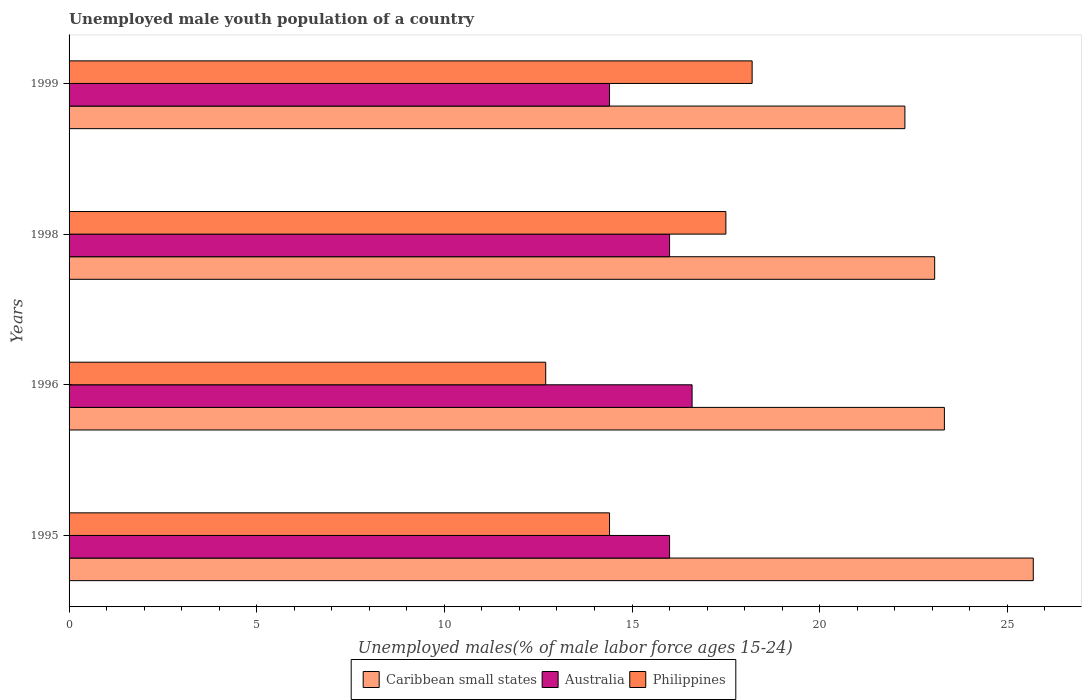How many different coloured bars are there?
Make the answer very short. 3. Are the number of bars per tick equal to the number of legend labels?
Your answer should be very brief. Yes. What is the label of the 1st group of bars from the top?
Provide a short and direct response. 1999. In how many cases, is the number of bars for a given year not equal to the number of legend labels?
Ensure brevity in your answer.  0. What is the percentage of unemployed male youth population in Caribbean small states in 1995?
Your answer should be compact. 25.69. Across all years, what is the maximum percentage of unemployed male youth population in Caribbean small states?
Your answer should be very brief. 25.69. Across all years, what is the minimum percentage of unemployed male youth population in Caribbean small states?
Make the answer very short. 22.27. In which year was the percentage of unemployed male youth population in Australia maximum?
Keep it short and to the point. 1996. What is the total percentage of unemployed male youth population in Caribbean small states in the graph?
Offer a very short reply. 94.35. What is the difference between the percentage of unemployed male youth population in Caribbean small states in 1995 and that in 1998?
Keep it short and to the point. 2.63. What is the difference between the percentage of unemployed male youth population in Australia in 1998 and the percentage of unemployed male youth population in Philippines in 1995?
Your answer should be compact. 1.6. What is the average percentage of unemployed male youth population in Australia per year?
Your answer should be compact. 15.75. In the year 1998, what is the difference between the percentage of unemployed male youth population in Caribbean small states and percentage of unemployed male youth population in Australia?
Ensure brevity in your answer.  7.06. What is the ratio of the percentage of unemployed male youth population in Caribbean small states in 1996 to that in 1999?
Your answer should be compact. 1.05. What is the difference between the highest and the second highest percentage of unemployed male youth population in Caribbean small states?
Make the answer very short. 2.37. What is the difference between the highest and the lowest percentage of unemployed male youth population in Caribbean small states?
Offer a very short reply. 3.42. What does the 3rd bar from the bottom in 1999 represents?
Give a very brief answer. Philippines. How many bars are there?
Provide a short and direct response. 12. Are all the bars in the graph horizontal?
Make the answer very short. Yes. What is the difference between two consecutive major ticks on the X-axis?
Keep it short and to the point. 5. What is the title of the graph?
Ensure brevity in your answer.  Unemployed male youth population of a country. What is the label or title of the X-axis?
Your response must be concise. Unemployed males(% of male labor force ages 15-24). What is the Unemployed males(% of male labor force ages 15-24) in Caribbean small states in 1995?
Provide a short and direct response. 25.69. What is the Unemployed males(% of male labor force ages 15-24) in Australia in 1995?
Keep it short and to the point. 16. What is the Unemployed males(% of male labor force ages 15-24) in Philippines in 1995?
Keep it short and to the point. 14.4. What is the Unemployed males(% of male labor force ages 15-24) of Caribbean small states in 1996?
Make the answer very short. 23.32. What is the Unemployed males(% of male labor force ages 15-24) of Australia in 1996?
Keep it short and to the point. 16.6. What is the Unemployed males(% of male labor force ages 15-24) in Philippines in 1996?
Provide a short and direct response. 12.7. What is the Unemployed males(% of male labor force ages 15-24) in Caribbean small states in 1998?
Provide a short and direct response. 23.06. What is the Unemployed males(% of male labor force ages 15-24) in Philippines in 1998?
Offer a terse response. 17.5. What is the Unemployed males(% of male labor force ages 15-24) of Caribbean small states in 1999?
Your answer should be compact. 22.27. What is the Unemployed males(% of male labor force ages 15-24) in Australia in 1999?
Offer a very short reply. 14.4. What is the Unemployed males(% of male labor force ages 15-24) of Philippines in 1999?
Keep it short and to the point. 18.2. Across all years, what is the maximum Unemployed males(% of male labor force ages 15-24) in Caribbean small states?
Make the answer very short. 25.69. Across all years, what is the maximum Unemployed males(% of male labor force ages 15-24) in Australia?
Offer a very short reply. 16.6. Across all years, what is the maximum Unemployed males(% of male labor force ages 15-24) of Philippines?
Ensure brevity in your answer.  18.2. Across all years, what is the minimum Unemployed males(% of male labor force ages 15-24) of Caribbean small states?
Keep it short and to the point. 22.27. Across all years, what is the minimum Unemployed males(% of male labor force ages 15-24) in Australia?
Your response must be concise. 14.4. Across all years, what is the minimum Unemployed males(% of male labor force ages 15-24) of Philippines?
Your answer should be very brief. 12.7. What is the total Unemployed males(% of male labor force ages 15-24) in Caribbean small states in the graph?
Make the answer very short. 94.35. What is the total Unemployed males(% of male labor force ages 15-24) of Philippines in the graph?
Give a very brief answer. 62.8. What is the difference between the Unemployed males(% of male labor force ages 15-24) in Caribbean small states in 1995 and that in 1996?
Your answer should be very brief. 2.37. What is the difference between the Unemployed males(% of male labor force ages 15-24) in Caribbean small states in 1995 and that in 1998?
Make the answer very short. 2.63. What is the difference between the Unemployed males(% of male labor force ages 15-24) of Philippines in 1995 and that in 1998?
Offer a terse response. -3.1. What is the difference between the Unemployed males(% of male labor force ages 15-24) of Caribbean small states in 1995 and that in 1999?
Offer a terse response. 3.42. What is the difference between the Unemployed males(% of male labor force ages 15-24) in Philippines in 1995 and that in 1999?
Provide a short and direct response. -3.8. What is the difference between the Unemployed males(% of male labor force ages 15-24) in Caribbean small states in 1996 and that in 1998?
Provide a short and direct response. 0.26. What is the difference between the Unemployed males(% of male labor force ages 15-24) in Philippines in 1996 and that in 1998?
Ensure brevity in your answer.  -4.8. What is the difference between the Unemployed males(% of male labor force ages 15-24) of Caribbean small states in 1996 and that in 1999?
Provide a succinct answer. 1.05. What is the difference between the Unemployed males(% of male labor force ages 15-24) in Australia in 1996 and that in 1999?
Ensure brevity in your answer.  2.2. What is the difference between the Unemployed males(% of male labor force ages 15-24) in Philippines in 1996 and that in 1999?
Provide a succinct answer. -5.5. What is the difference between the Unemployed males(% of male labor force ages 15-24) of Caribbean small states in 1998 and that in 1999?
Keep it short and to the point. 0.79. What is the difference between the Unemployed males(% of male labor force ages 15-24) in Caribbean small states in 1995 and the Unemployed males(% of male labor force ages 15-24) in Australia in 1996?
Provide a succinct answer. 9.09. What is the difference between the Unemployed males(% of male labor force ages 15-24) of Caribbean small states in 1995 and the Unemployed males(% of male labor force ages 15-24) of Philippines in 1996?
Your answer should be compact. 12.99. What is the difference between the Unemployed males(% of male labor force ages 15-24) of Australia in 1995 and the Unemployed males(% of male labor force ages 15-24) of Philippines in 1996?
Make the answer very short. 3.3. What is the difference between the Unemployed males(% of male labor force ages 15-24) of Caribbean small states in 1995 and the Unemployed males(% of male labor force ages 15-24) of Australia in 1998?
Give a very brief answer. 9.69. What is the difference between the Unemployed males(% of male labor force ages 15-24) in Caribbean small states in 1995 and the Unemployed males(% of male labor force ages 15-24) in Philippines in 1998?
Your answer should be compact. 8.19. What is the difference between the Unemployed males(% of male labor force ages 15-24) in Caribbean small states in 1995 and the Unemployed males(% of male labor force ages 15-24) in Australia in 1999?
Provide a succinct answer. 11.29. What is the difference between the Unemployed males(% of male labor force ages 15-24) of Caribbean small states in 1995 and the Unemployed males(% of male labor force ages 15-24) of Philippines in 1999?
Ensure brevity in your answer.  7.49. What is the difference between the Unemployed males(% of male labor force ages 15-24) in Australia in 1995 and the Unemployed males(% of male labor force ages 15-24) in Philippines in 1999?
Provide a succinct answer. -2.2. What is the difference between the Unemployed males(% of male labor force ages 15-24) in Caribbean small states in 1996 and the Unemployed males(% of male labor force ages 15-24) in Australia in 1998?
Provide a short and direct response. 7.32. What is the difference between the Unemployed males(% of male labor force ages 15-24) of Caribbean small states in 1996 and the Unemployed males(% of male labor force ages 15-24) of Philippines in 1998?
Give a very brief answer. 5.82. What is the difference between the Unemployed males(% of male labor force ages 15-24) in Caribbean small states in 1996 and the Unemployed males(% of male labor force ages 15-24) in Australia in 1999?
Provide a succinct answer. 8.92. What is the difference between the Unemployed males(% of male labor force ages 15-24) in Caribbean small states in 1996 and the Unemployed males(% of male labor force ages 15-24) in Philippines in 1999?
Keep it short and to the point. 5.12. What is the difference between the Unemployed males(% of male labor force ages 15-24) in Australia in 1996 and the Unemployed males(% of male labor force ages 15-24) in Philippines in 1999?
Offer a very short reply. -1.6. What is the difference between the Unemployed males(% of male labor force ages 15-24) in Caribbean small states in 1998 and the Unemployed males(% of male labor force ages 15-24) in Australia in 1999?
Offer a very short reply. 8.66. What is the difference between the Unemployed males(% of male labor force ages 15-24) in Caribbean small states in 1998 and the Unemployed males(% of male labor force ages 15-24) in Philippines in 1999?
Keep it short and to the point. 4.86. What is the average Unemployed males(% of male labor force ages 15-24) in Caribbean small states per year?
Ensure brevity in your answer.  23.59. What is the average Unemployed males(% of male labor force ages 15-24) of Australia per year?
Make the answer very short. 15.75. What is the average Unemployed males(% of male labor force ages 15-24) in Philippines per year?
Ensure brevity in your answer.  15.7. In the year 1995, what is the difference between the Unemployed males(% of male labor force ages 15-24) of Caribbean small states and Unemployed males(% of male labor force ages 15-24) of Australia?
Offer a very short reply. 9.69. In the year 1995, what is the difference between the Unemployed males(% of male labor force ages 15-24) in Caribbean small states and Unemployed males(% of male labor force ages 15-24) in Philippines?
Give a very brief answer. 11.29. In the year 1995, what is the difference between the Unemployed males(% of male labor force ages 15-24) in Australia and Unemployed males(% of male labor force ages 15-24) in Philippines?
Provide a succinct answer. 1.6. In the year 1996, what is the difference between the Unemployed males(% of male labor force ages 15-24) in Caribbean small states and Unemployed males(% of male labor force ages 15-24) in Australia?
Give a very brief answer. 6.72. In the year 1996, what is the difference between the Unemployed males(% of male labor force ages 15-24) of Caribbean small states and Unemployed males(% of male labor force ages 15-24) of Philippines?
Give a very brief answer. 10.62. In the year 1996, what is the difference between the Unemployed males(% of male labor force ages 15-24) of Australia and Unemployed males(% of male labor force ages 15-24) of Philippines?
Provide a short and direct response. 3.9. In the year 1998, what is the difference between the Unemployed males(% of male labor force ages 15-24) of Caribbean small states and Unemployed males(% of male labor force ages 15-24) of Australia?
Give a very brief answer. 7.06. In the year 1998, what is the difference between the Unemployed males(% of male labor force ages 15-24) in Caribbean small states and Unemployed males(% of male labor force ages 15-24) in Philippines?
Make the answer very short. 5.56. In the year 1998, what is the difference between the Unemployed males(% of male labor force ages 15-24) in Australia and Unemployed males(% of male labor force ages 15-24) in Philippines?
Give a very brief answer. -1.5. In the year 1999, what is the difference between the Unemployed males(% of male labor force ages 15-24) in Caribbean small states and Unemployed males(% of male labor force ages 15-24) in Australia?
Offer a very short reply. 7.87. In the year 1999, what is the difference between the Unemployed males(% of male labor force ages 15-24) of Caribbean small states and Unemployed males(% of male labor force ages 15-24) of Philippines?
Your answer should be very brief. 4.07. What is the ratio of the Unemployed males(% of male labor force ages 15-24) in Caribbean small states in 1995 to that in 1996?
Provide a short and direct response. 1.1. What is the ratio of the Unemployed males(% of male labor force ages 15-24) in Australia in 1995 to that in 1996?
Offer a terse response. 0.96. What is the ratio of the Unemployed males(% of male labor force ages 15-24) of Philippines in 1995 to that in 1996?
Ensure brevity in your answer.  1.13. What is the ratio of the Unemployed males(% of male labor force ages 15-24) in Caribbean small states in 1995 to that in 1998?
Offer a very short reply. 1.11. What is the ratio of the Unemployed males(% of male labor force ages 15-24) in Philippines in 1995 to that in 1998?
Keep it short and to the point. 0.82. What is the ratio of the Unemployed males(% of male labor force ages 15-24) in Caribbean small states in 1995 to that in 1999?
Your answer should be compact. 1.15. What is the ratio of the Unemployed males(% of male labor force ages 15-24) in Australia in 1995 to that in 1999?
Ensure brevity in your answer.  1.11. What is the ratio of the Unemployed males(% of male labor force ages 15-24) of Philippines in 1995 to that in 1999?
Make the answer very short. 0.79. What is the ratio of the Unemployed males(% of male labor force ages 15-24) of Caribbean small states in 1996 to that in 1998?
Offer a very short reply. 1.01. What is the ratio of the Unemployed males(% of male labor force ages 15-24) in Australia in 1996 to that in 1998?
Make the answer very short. 1.04. What is the ratio of the Unemployed males(% of male labor force ages 15-24) in Philippines in 1996 to that in 1998?
Your answer should be compact. 0.73. What is the ratio of the Unemployed males(% of male labor force ages 15-24) of Caribbean small states in 1996 to that in 1999?
Provide a succinct answer. 1.05. What is the ratio of the Unemployed males(% of male labor force ages 15-24) in Australia in 1996 to that in 1999?
Make the answer very short. 1.15. What is the ratio of the Unemployed males(% of male labor force ages 15-24) in Philippines in 1996 to that in 1999?
Your response must be concise. 0.7. What is the ratio of the Unemployed males(% of male labor force ages 15-24) of Caribbean small states in 1998 to that in 1999?
Your answer should be very brief. 1.04. What is the ratio of the Unemployed males(% of male labor force ages 15-24) of Australia in 1998 to that in 1999?
Your answer should be compact. 1.11. What is the ratio of the Unemployed males(% of male labor force ages 15-24) in Philippines in 1998 to that in 1999?
Your answer should be very brief. 0.96. What is the difference between the highest and the second highest Unemployed males(% of male labor force ages 15-24) of Caribbean small states?
Your answer should be compact. 2.37. What is the difference between the highest and the second highest Unemployed males(% of male labor force ages 15-24) in Philippines?
Your response must be concise. 0.7. What is the difference between the highest and the lowest Unemployed males(% of male labor force ages 15-24) of Caribbean small states?
Your response must be concise. 3.42. 